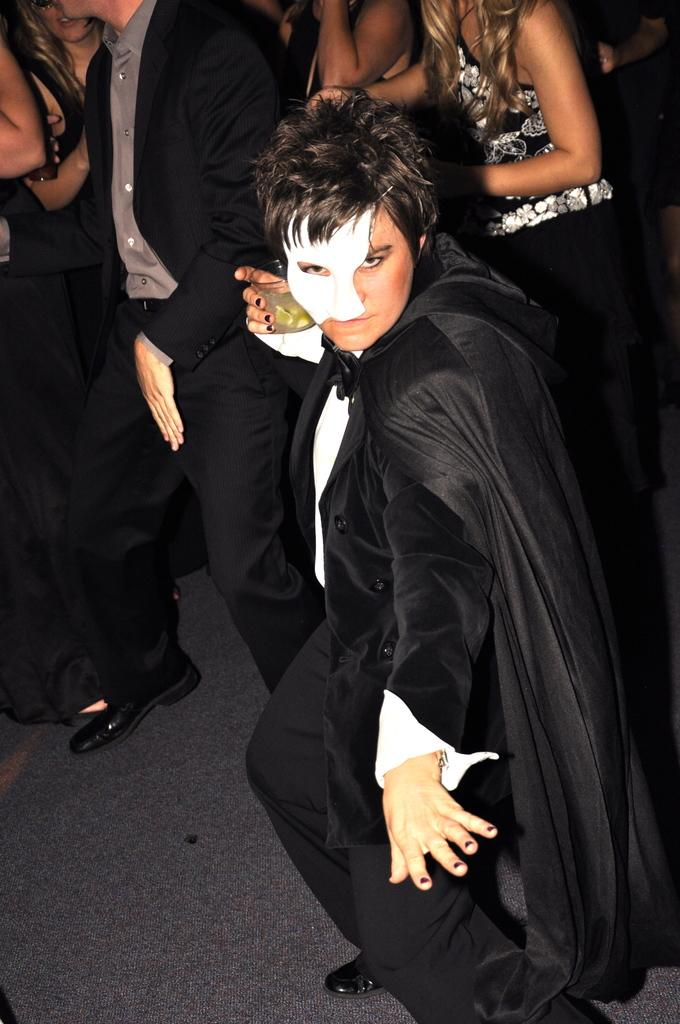How many people are in the image? There are people in the image, but the exact number is not specified. What is one person wearing in the image? One person is wearing a mask in the image. What is the person wearing a mask holding? The person wearing a mask is holding a glass in the image. What is the person wearing a mask doing? The person wearing a mask is posing for a photo in the image. What day of the week is depicted in the image? The facts provided do not mention any specific day of the week, so it cannot be determined from the image. 